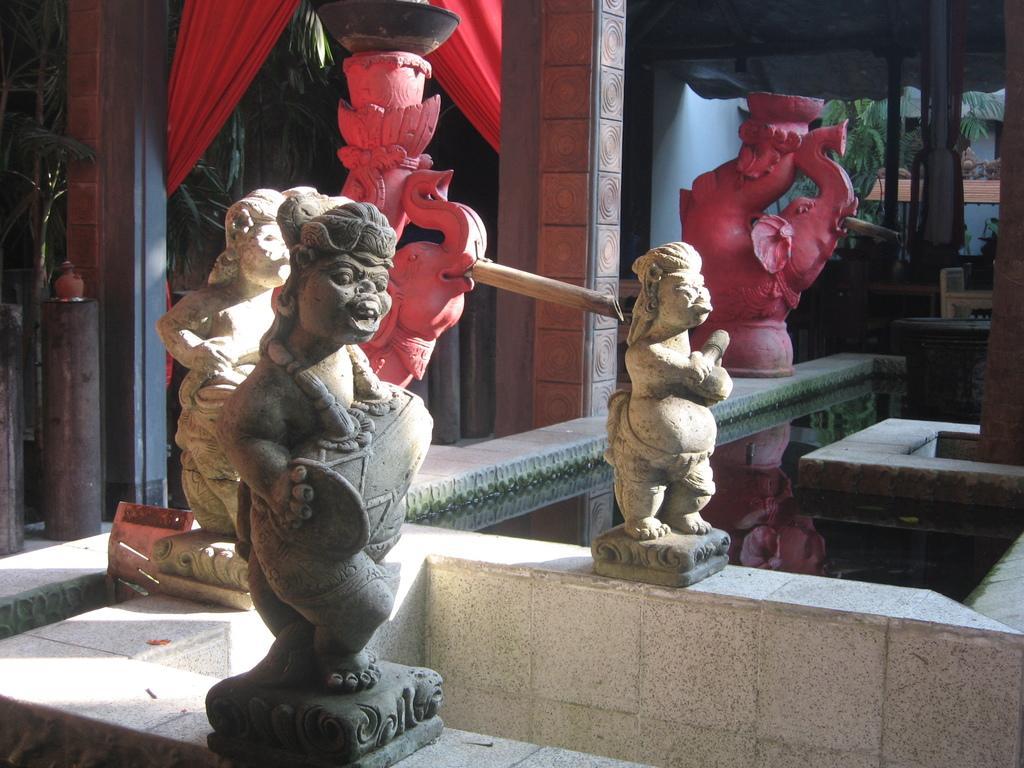Can you describe this image briefly? In this picture we can observe sculptures which are in grey and pink colors. We can observe pillars. There are two red color curtains. In the background there are trees. 